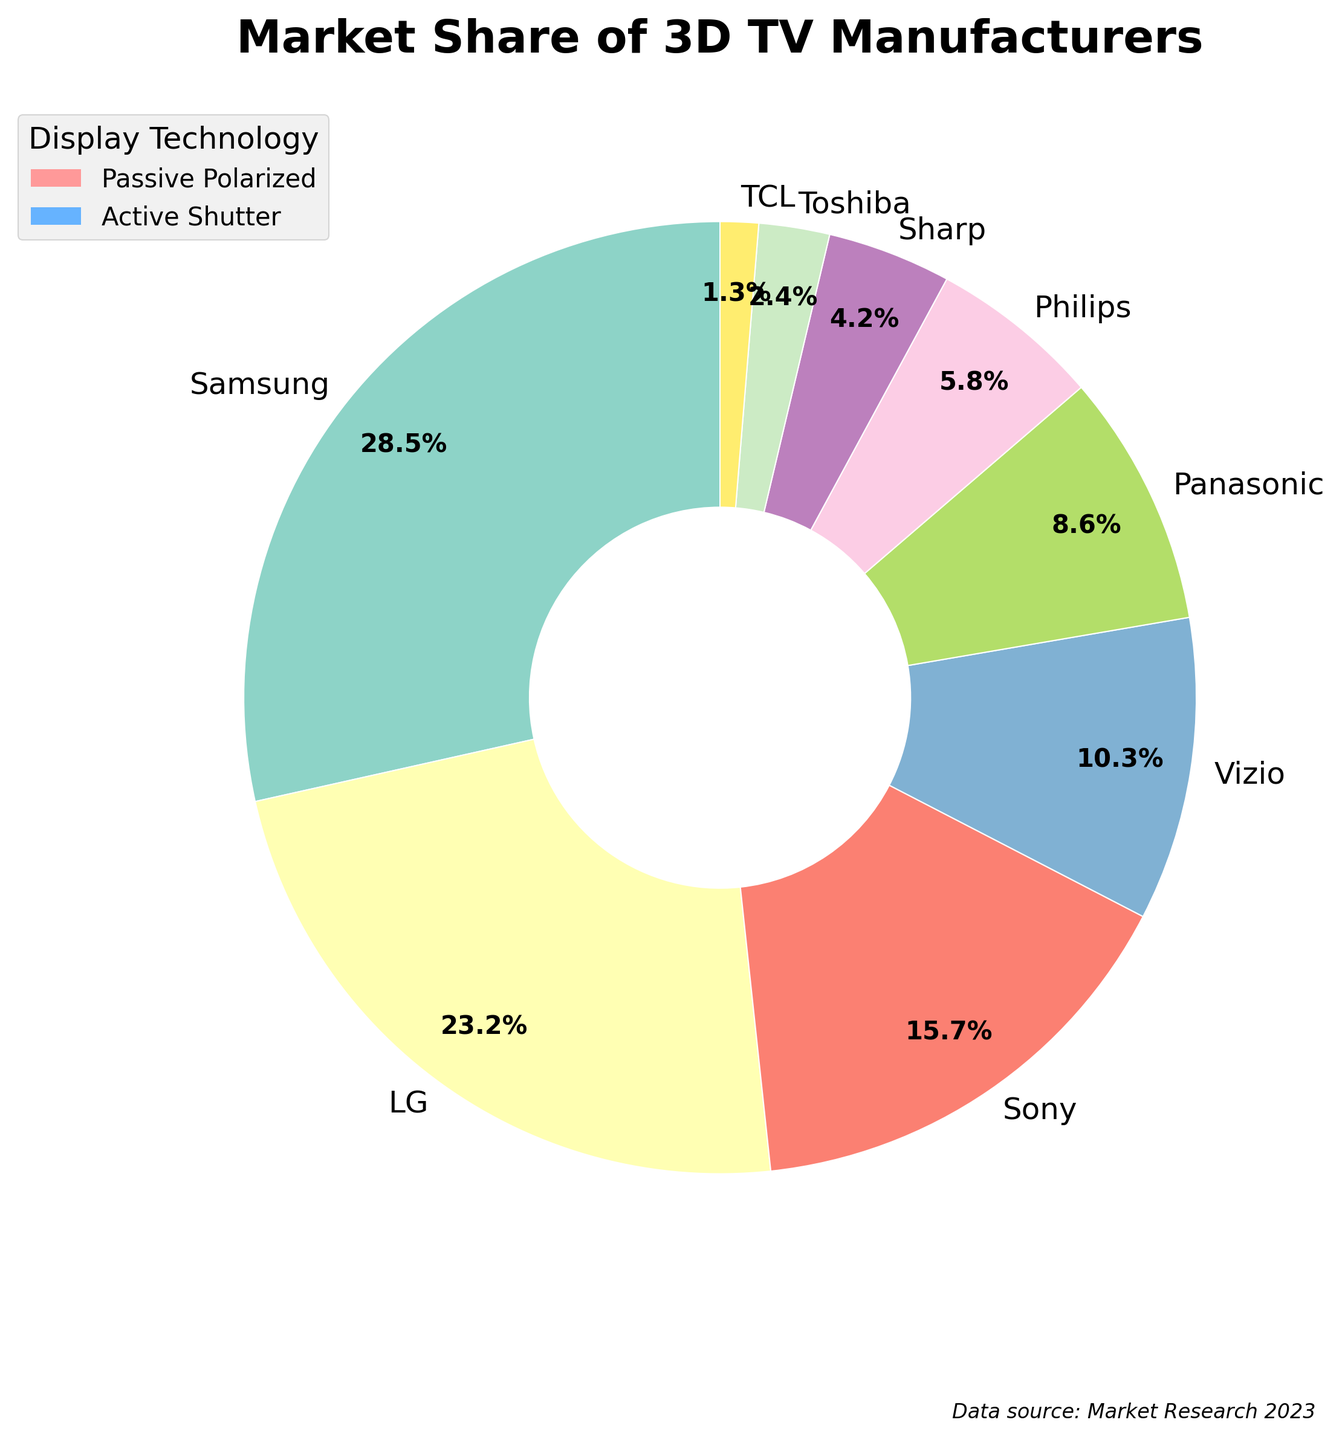What percentage of the market share is held by manufacturers using the Active Shutter technology? To find the percentage of the market share held by manufacturers using the Active Shutter technology, we sum the market shares for Samsung (28.5%), Sony (15.7%), Panasonic (8.6%), Sharp (4.2%), and TCL (1.3%). This gives us 28.5 + 15.7 + 8.6 + 4.2 + 1.3 = 58.3%.
Answer: 58.3% Which manufacturer has the highest market share and what display technology do they use? Samsung has the highest market share at 28.5%, and they use Active Shutter technology as indicated in the chart.
Answer: Samsung, Active Shutter Who has a larger market share, LG or Sony, and by how much? LG has a market share of 23.2%, while Sony has 15.7%. LG's market share is larger by 23.2 - 15.7 = 7.5%.
Answer: LG, 7.5% Combine the market shares of manufacturers using Passive Polarized technology. How does it compare to the market share of Samsung? Sum the market shares of LG (23.2%), Vizio (10.3%), Philips (5.8%), and Toshiba (2.4%), which gives 23.2 + 10.3 + 5.8 + 2.4 = 41.7%. Samsung alone has 28.5%. Therefore, Passive Polarized manufacturers collectively have 41.7%, which is higher than Samsung's 28.5%.
Answer: 41.7%, higher What is the combined market share of the three smallest manufacturers? The three smallest manufacturers are TCL (1.3%), Toshiba (2.4%), and Sharp (4.2%). The combined market share is 1.3 + 2.4 + 4.2 = 7.9%.
Answer: 7.9% Which technology has more color segments in the pie chart, and how many segments does each have? The Active Shutter technology has more color segments in the pie chart. Active Shutter counts to 5 segments (Samsung, Sony, Panasonic, Sharp, and TCL), while Passive Polarized has 4 segments (LG, Vizio, Philips, and Toshiba).
Answer: Active Shutter: 5, Passive Polarized: 4 What is the average market share of manufacturers using Passive Polarized technology? The manufacturers using Passive Polarized technology are LG (23.2%), Vizio (10.3%), Philips (5.8%), and Toshiba (2.4%). To find the average, sum these: 23.2 + 10.3 + 5.8 + 2.4 = 41.7. Divide by the number of manufacturers: 41.7 / 4 = 10.425%.
Answer: 10.425% Is there any manufacturer that holds a market share between 5% and 10%? If so, who are they and what are their respective shares? Yes, there are two manufacturers holding a market share between 5% and 10%. They are Panasonic with 8.6% and Philips with 5.8%.
Answer: Panasonic (8.6%), Philips (5.8%) How does the market share of Vizio compare to that of Panasonic? Vizio has a market share of 10.3%, while Panasonic has 8.6%. Vizio's market share is greater by 10.3 - 8.6 = 1.7%.
Answer: Vizio, 1.7% What is the total market share held by all manufacturers combined, and does it sum to 100%? To find the total market share, sum all the individual market shares: 28.5 + 23.2 + 15.7 + 10.3 + 8.6 + 5.8 + 4.2 + 2.4 + 1.3 = 100%. Yes, it sums to 100%.
Answer: 100%, yes 